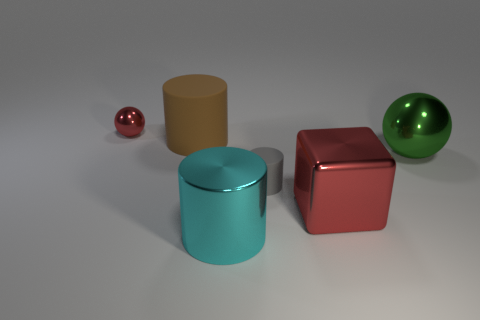Add 4 large brown shiny objects. How many objects exist? 10 Subtract all big cylinders. How many cylinders are left? 1 Add 2 gray rubber cubes. How many gray rubber cubes exist? 2 Subtract all brown cylinders. How many cylinders are left? 2 Subtract 0 yellow blocks. How many objects are left? 6 Subtract all cubes. How many objects are left? 5 Subtract 2 spheres. How many spheres are left? 0 Subtract all cyan spheres. Subtract all green cylinders. How many spheres are left? 2 Subtract all red blocks. How many green spheres are left? 1 Subtract all big metal spheres. Subtract all tiny cylinders. How many objects are left? 4 